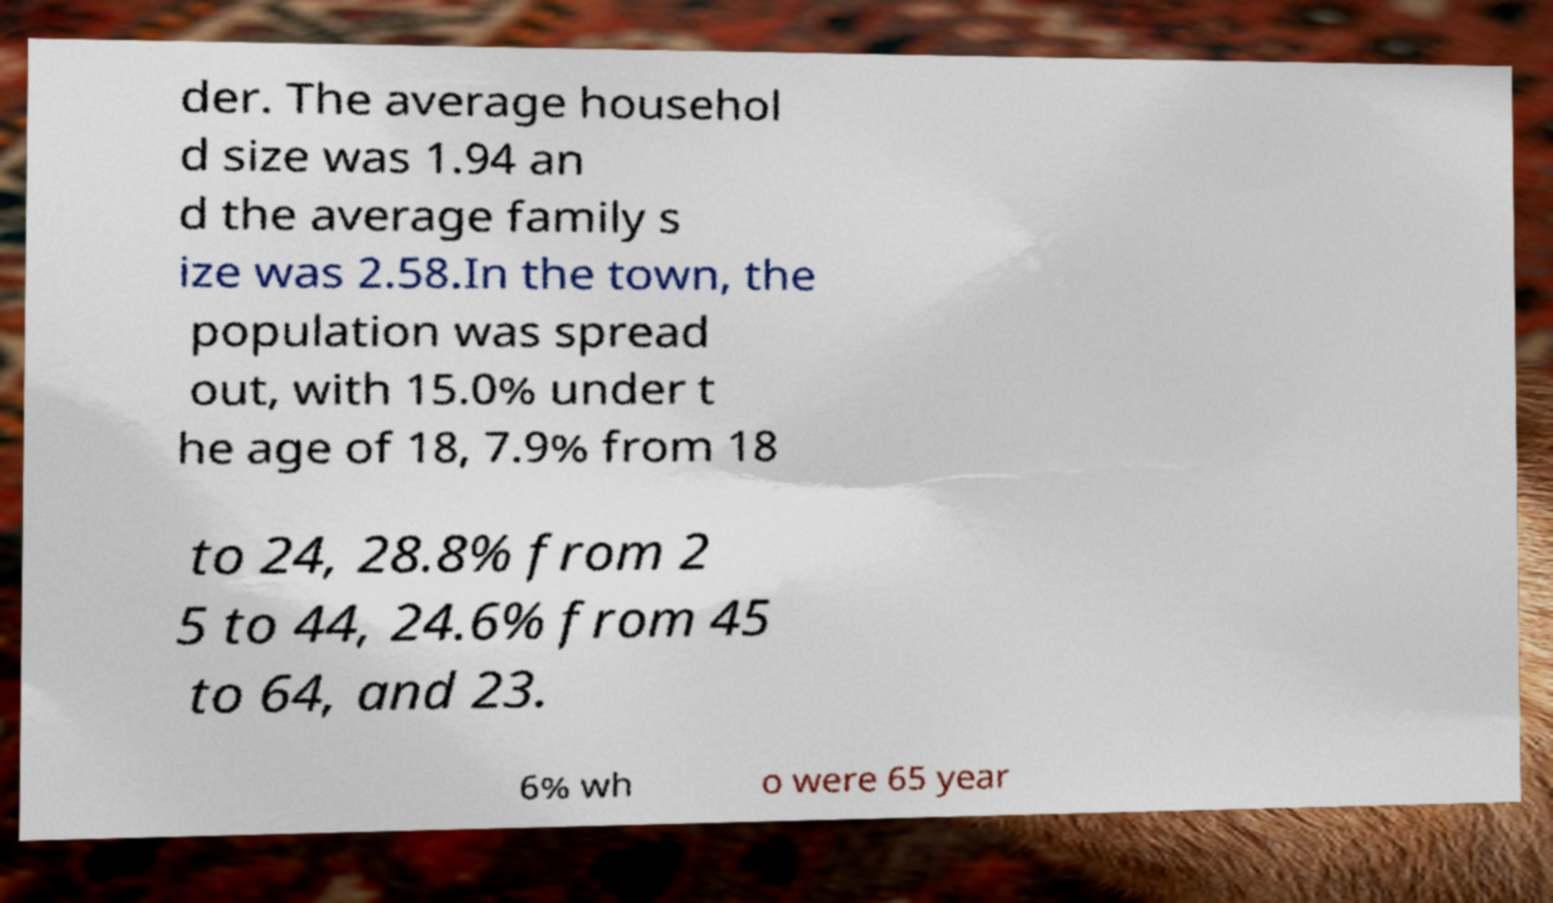Could you assist in decoding the text presented in this image and type it out clearly? der. The average househol d size was 1.94 an d the average family s ize was 2.58.In the town, the population was spread out, with 15.0% under t he age of 18, 7.9% from 18 to 24, 28.8% from 2 5 to 44, 24.6% from 45 to 64, and 23. 6% wh o were 65 year 